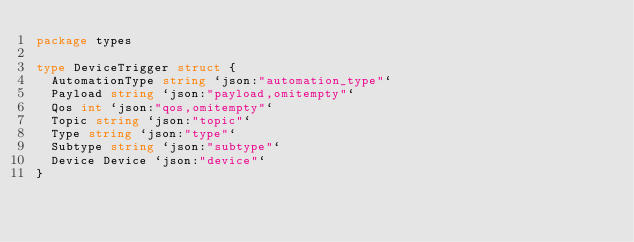<code> <loc_0><loc_0><loc_500><loc_500><_Go_>package types

type DeviceTrigger struct {
	AutomationType string `json:"automation_type"`
	Payload string `json:"payload,omitempty"`
	Qos int `json:"qos,omitempty"`
	Topic string `json:"topic"`
	Type string `json:"type"`
	Subtype string `json:"subtype"`
	Device Device `json:"device"`
}

</code> 